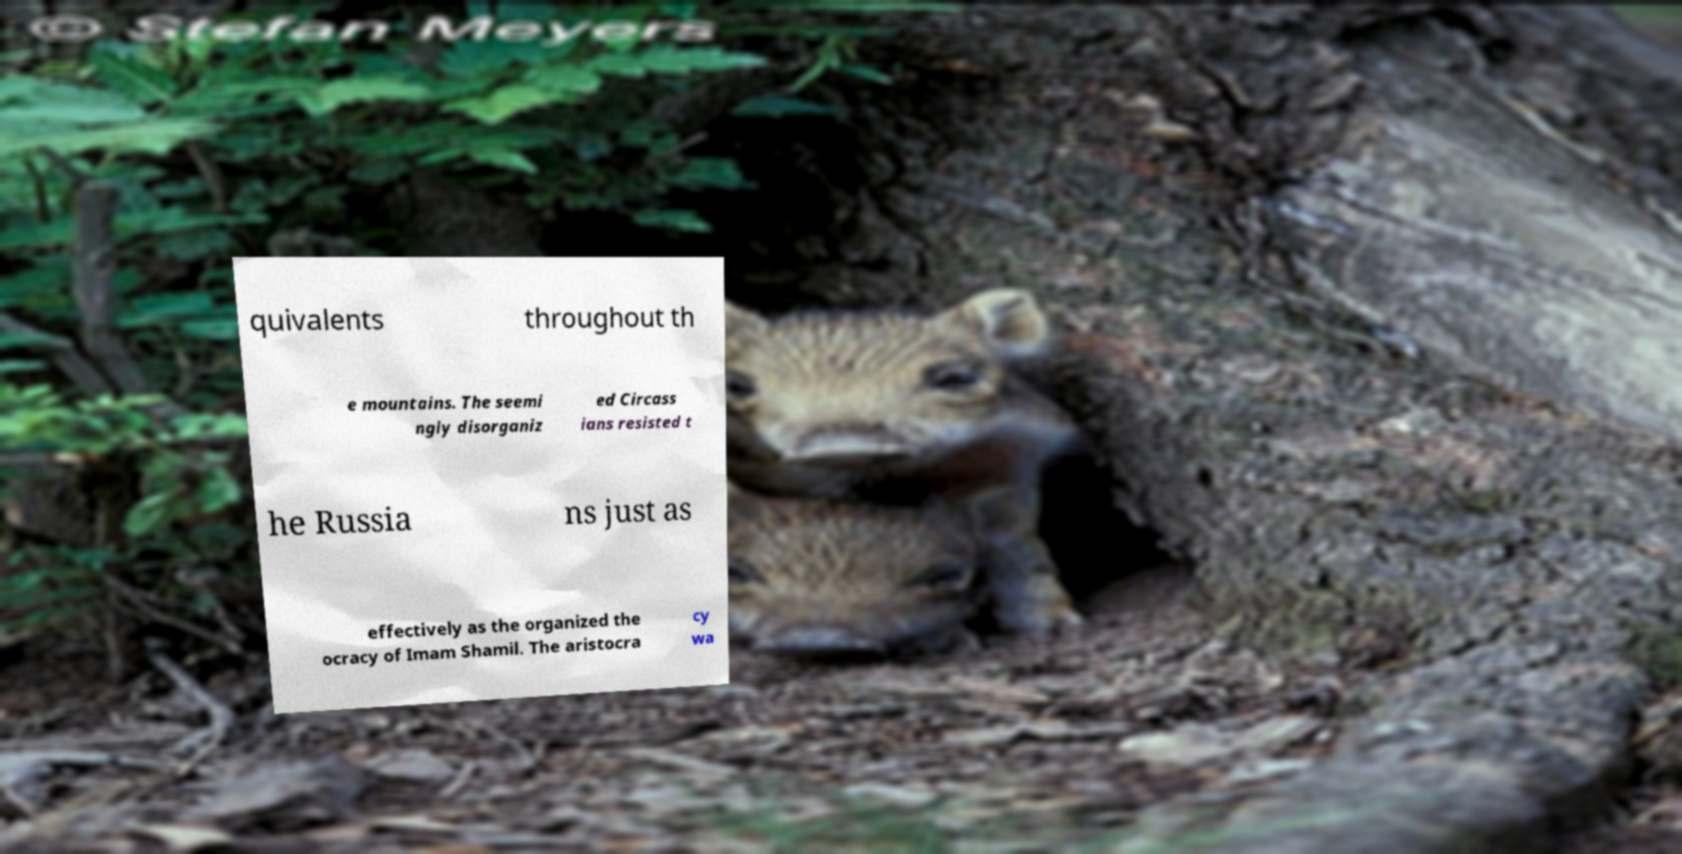There's text embedded in this image that I need extracted. Can you transcribe it verbatim? quivalents throughout th e mountains. The seemi ngly disorganiz ed Circass ians resisted t he Russia ns just as effectively as the organized the ocracy of Imam Shamil. The aristocra cy wa 